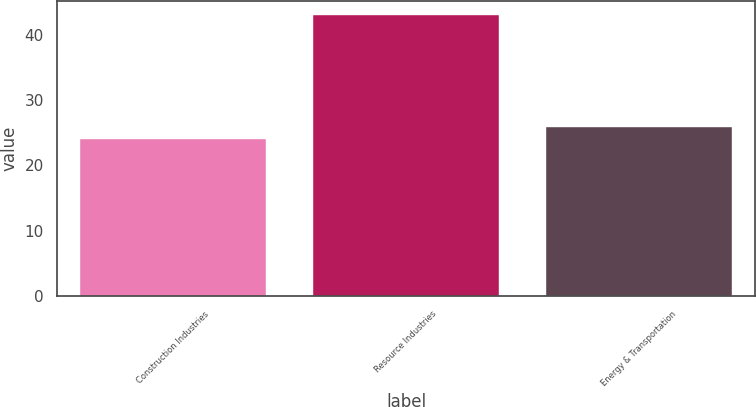Convert chart. <chart><loc_0><loc_0><loc_500><loc_500><bar_chart><fcel>Construction Industries<fcel>Resource Industries<fcel>Energy & Transportation<nl><fcel>24<fcel>43<fcel>25.9<nl></chart> 